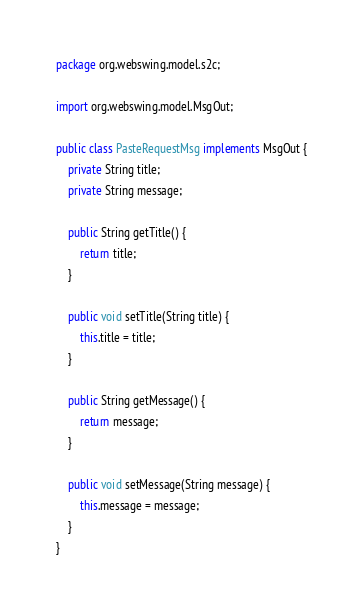<code> <loc_0><loc_0><loc_500><loc_500><_Java_>package org.webswing.model.s2c;

import org.webswing.model.MsgOut;

public class PasteRequestMsg implements MsgOut {
	private String title;
	private String message;

	public String getTitle() {
		return title;
	}

	public void setTitle(String title) {
		this.title = title;
	}

	public String getMessage() {
		return message;
	}

	public void setMessage(String message) {
		this.message = message;
	}
}
</code> 